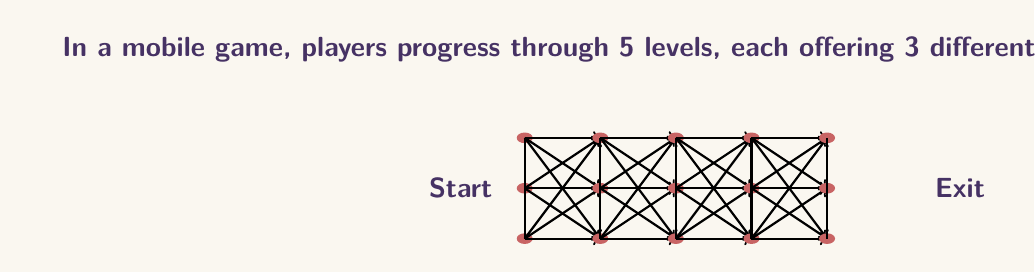Could you help me with this problem? Let's approach this step-by-step:

1) First, let's consider the number of ways to complete all 5 levels:
   - At each level, there are 3 path choices
   - There are 5 levels in total
   - So, the number of ways to complete all levels is $3^5 = 243$

2) Now, let's consider the paths where players exit early:
   - After level 1: 3 paths
   - After level 2: $3 \times 3 = 9$ paths
   - After level 3: $3 \times 3 \times 3 = 27$ paths
   - After level 4: $3 \times 3 \times 3 \times 3 = 81$ paths

3) To calculate the total number of paths, we sum all these possibilities:
   $$ \text{Total paths} = 243 + 81 + 27 + 9 + 3 = 363 $$

4) We can also express this as a sum:
   $$ \sum_{i=1}^5 3^i = 3 + 3^2 + 3^3 + 3^4 + 3^5 = 363 $$

This sum represents all possible paths, including those where players exit at any level or complete all levels.
Answer: 363 